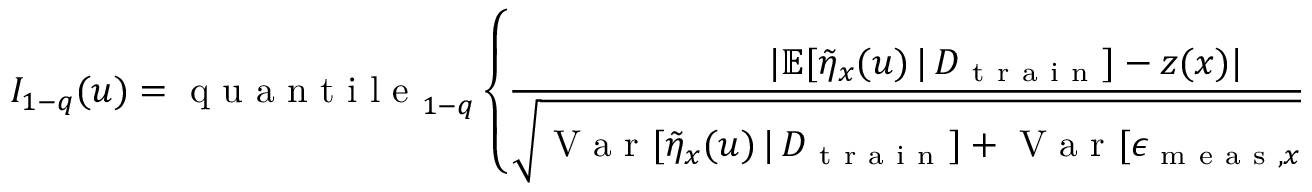<formula> <loc_0><loc_0><loc_500><loc_500>I _ { 1 - q } ( u ) = q u a n t i l e _ { 1 - q } \left \{ \frac { | \mathbb { E } [ \tilde { \eta } _ { x } ( u ) \, | \, D _ { t r a i n } ] - z ( x ) | } { \sqrt { V a r [ \tilde { \eta } _ { x } ( u ) \, | \, D _ { t r a i n } ] + V a r [ \epsilon _ { m e a s , x } ] + \hat { \delta } _ { M L E } ^ { 2 } } } \colon x \in \mathcal { M } ^ { * } \right \} ,</formula> 